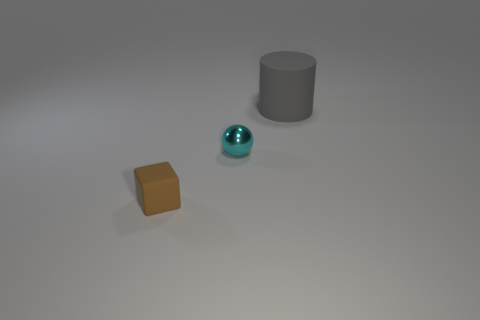Is there anything else that is made of the same material as the tiny cyan thing? Based on the visual information provided, it is challenging to ascertain the exact materials of the objects with certainty. However, the tiny cyan object appears to have a reflective surface similar to that of a glass or a polished metal. No other objects in the image exhibit identical reflective qualities to suggest they are made of the same material. 